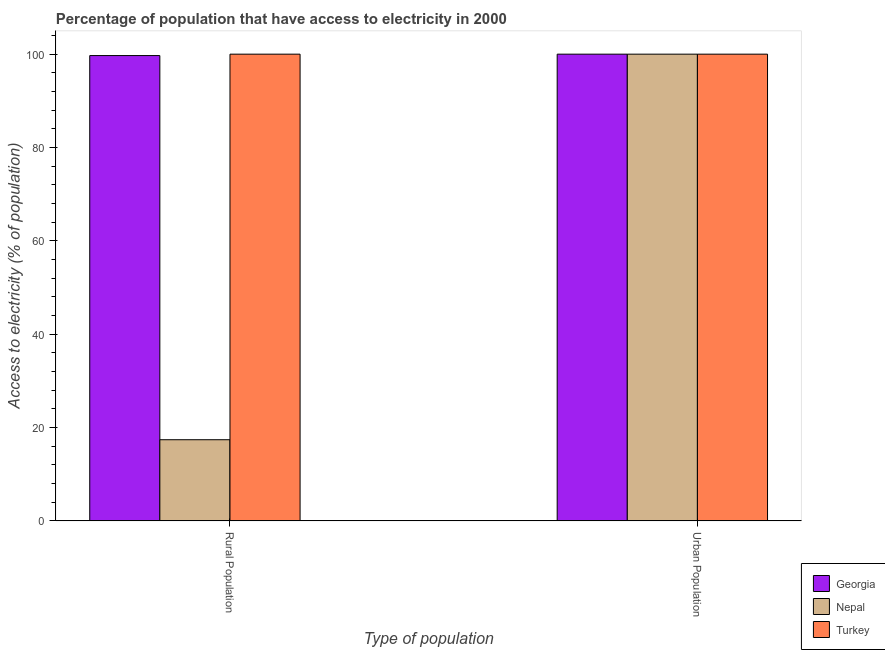How many groups of bars are there?
Make the answer very short. 2. Are the number of bars per tick equal to the number of legend labels?
Ensure brevity in your answer.  Yes. Are the number of bars on each tick of the X-axis equal?
Give a very brief answer. Yes. How many bars are there on the 2nd tick from the left?
Ensure brevity in your answer.  3. How many bars are there on the 1st tick from the right?
Give a very brief answer. 3. What is the label of the 1st group of bars from the left?
Keep it short and to the point. Rural Population. In which country was the percentage of urban population having access to electricity maximum?
Keep it short and to the point. Georgia. In which country was the percentage of urban population having access to electricity minimum?
Your answer should be very brief. Georgia. What is the total percentage of urban population having access to electricity in the graph?
Offer a very short reply. 300. What is the difference between the percentage of urban population having access to electricity in Turkey and the percentage of rural population having access to electricity in Nepal?
Make the answer very short. 82.6. What is the average percentage of rural population having access to electricity per country?
Give a very brief answer. 72.37. What is the difference between the percentage of rural population having access to electricity and percentage of urban population having access to electricity in Nepal?
Your answer should be very brief. -82.6. What is the ratio of the percentage of rural population having access to electricity in Georgia to that in Turkey?
Offer a terse response. 1. Is the percentage of urban population having access to electricity in Turkey less than that in Georgia?
Provide a succinct answer. No. What does the 2nd bar from the left in Rural Population represents?
Provide a short and direct response. Nepal. How many bars are there?
Offer a terse response. 6. Does the graph contain grids?
Your answer should be compact. No. Where does the legend appear in the graph?
Provide a succinct answer. Bottom right. What is the title of the graph?
Offer a very short reply. Percentage of population that have access to electricity in 2000. Does "Japan" appear as one of the legend labels in the graph?
Provide a short and direct response. No. What is the label or title of the X-axis?
Give a very brief answer. Type of population. What is the label or title of the Y-axis?
Provide a succinct answer. Access to electricity (% of population). What is the Access to electricity (% of population) in Georgia in Rural Population?
Ensure brevity in your answer.  99.7. What is the Access to electricity (% of population) in Turkey in Rural Population?
Provide a short and direct response. 100. What is the Access to electricity (% of population) of Nepal in Urban Population?
Give a very brief answer. 100. Across all Type of population, what is the maximum Access to electricity (% of population) in Georgia?
Provide a short and direct response. 100. Across all Type of population, what is the maximum Access to electricity (% of population) of Nepal?
Offer a very short reply. 100. Across all Type of population, what is the maximum Access to electricity (% of population) of Turkey?
Ensure brevity in your answer.  100. Across all Type of population, what is the minimum Access to electricity (% of population) in Georgia?
Give a very brief answer. 99.7. What is the total Access to electricity (% of population) of Georgia in the graph?
Give a very brief answer. 199.7. What is the total Access to electricity (% of population) in Nepal in the graph?
Make the answer very short. 117.4. What is the total Access to electricity (% of population) in Turkey in the graph?
Your response must be concise. 200. What is the difference between the Access to electricity (% of population) of Georgia in Rural Population and that in Urban Population?
Your response must be concise. -0.3. What is the difference between the Access to electricity (% of population) of Nepal in Rural Population and that in Urban Population?
Make the answer very short. -82.6. What is the difference between the Access to electricity (% of population) of Turkey in Rural Population and that in Urban Population?
Your response must be concise. 0. What is the difference between the Access to electricity (% of population) in Georgia in Rural Population and the Access to electricity (% of population) in Turkey in Urban Population?
Your answer should be very brief. -0.3. What is the difference between the Access to electricity (% of population) of Nepal in Rural Population and the Access to electricity (% of population) of Turkey in Urban Population?
Your answer should be very brief. -82.6. What is the average Access to electricity (% of population) of Georgia per Type of population?
Keep it short and to the point. 99.85. What is the average Access to electricity (% of population) of Nepal per Type of population?
Ensure brevity in your answer.  58.7. What is the average Access to electricity (% of population) of Turkey per Type of population?
Give a very brief answer. 100. What is the difference between the Access to electricity (% of population) in Georgia and Access to electricity (% of population) in Nepal in Rural Population?
Offer a very short reply. 82.3. What is the difference between the Access to electricity (% of population) of Georgia and Access to electricity (% of population) of Turkey in Rural Population?
Your answer should be compact. -0.3. What is the difference between the Access to electricity (% of population) of Nepal and Access to electricity (% of population) of Turkey in Rural Population?
Your answer should be compact. -82.6. What is the difference between the Access to electricity (% of population) of Georgia and Access to electricity (% of population) of Nepal in Urban Population?
Make the answer very short. 0. What is the difference between the Access to electricity (% of population) in Georgia and Access to electricity (% of population) in Turkey in Urban Population?
Ensure brevity in your answer.  0. What is the difference between the Access to electricity (% of population) of Nepal and Access to electricity (% of population) of Turkey in Urban Population?
Provide a short and direct response. 0. What is the ratio of the Access to electricity (% of population) in Georgia in Rural Population to that in Urban Population?
Your response must be concise. 1. What is the ratio of the Access to electricity (% of population) in Nepal in Rural Population to that in Urban Population?
Your answer should be compact. 0.17. What is the difference between the highest and the second highest Access to electricity (% of population) of Nepal?
Your answer should be very brief. 82.6. What is the difference between the highest and the lowest Access to electricity (% of population) of Georgia?
Keep it short and to the point. 0.3. What is the difference between the highest and the lowest Access to electricity (% of population) in Nepal?
Your answer should be compact. 82.6. What is the difference between the highest and the lowest Access to electricity (% of population) of Turkey?
Provide a short and direct response. 0. 